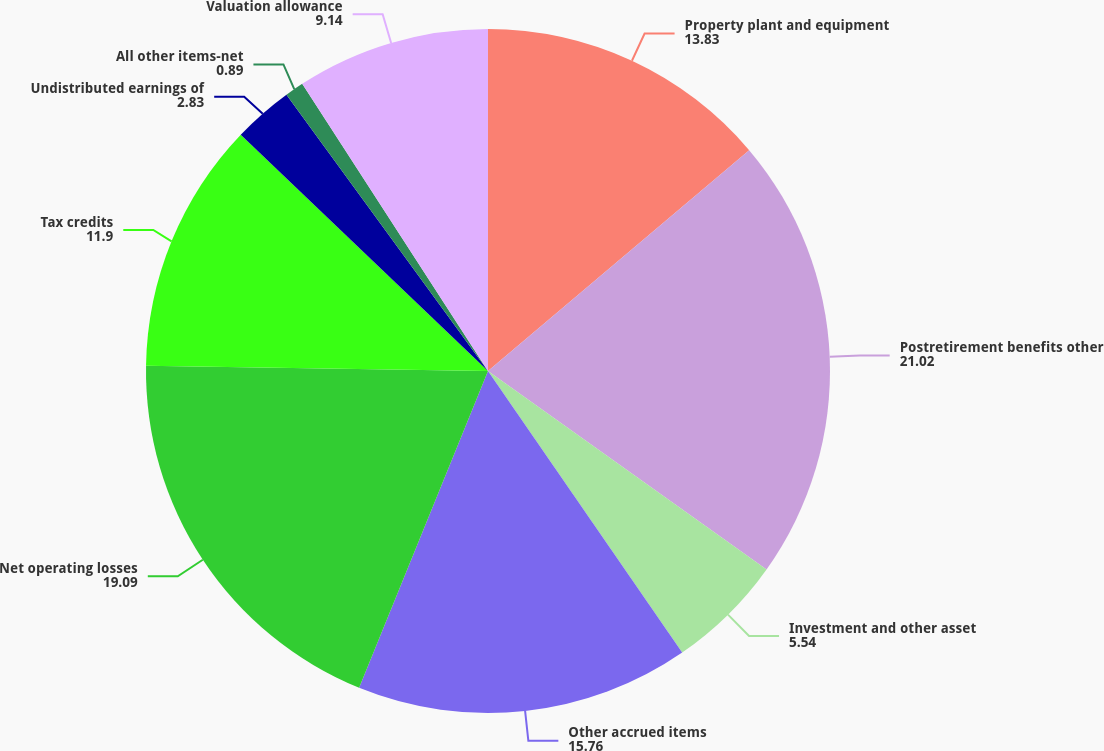Convert chart to OTSL. <chart><loc_0><loc_0><loc_500><loc_500><pie_chart><fcel>Property plant and equipment<fcel>Postretirement benefits other<fcel>Investment and other asset<fcel>Other accrued items<fcel>Net operating losses<fcel>Tax credits<fcel>Undistributed earnings of<fcel>All other items-net<fcel>Valuation allowance<nl><fcel>13.83%<fcel>21.02%<fcel>5.54%<fcel>15.76%<fcel>19.09%<fcel>11.9%<fcel>2.83%<fcel>0.89%<fcel>9.14%<nl></chart> 